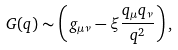Convert formula to latex. <formula><loc_0><loc_0><loc_500><loc_500>G ( q ) \sim \left ( g _ { \mu \nu } - \xi \frac { q _ { \mu } q _ { \nu } } { q ^ { 2 } } \right ) , \</formula> 